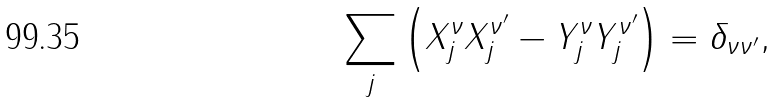<formula> <loc_0><loc_0><loc_500><loc_500>\sum _ { j } \left ( X _ { j } ^ { \nu } X _ { j } ^ { \nu ^ { \prime } } - Y _ { j } ^ { \nu } Y _ { j } ^ { \nu ^ { \prime } } \right ) = \delta _ { \nu \nu ^ { \prime } } ,</formula> 